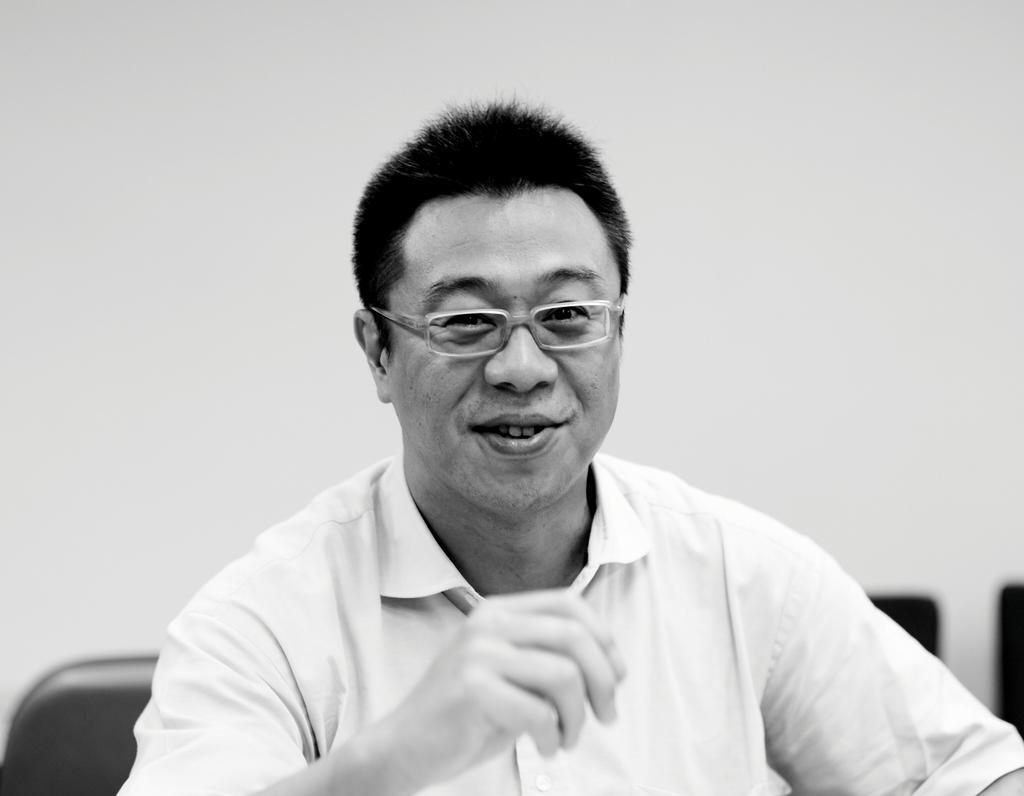Describe this image in one or two sentences. In this image there is a person wearing specs is smiling. In the back there is a wall. And this is a black and white image. 